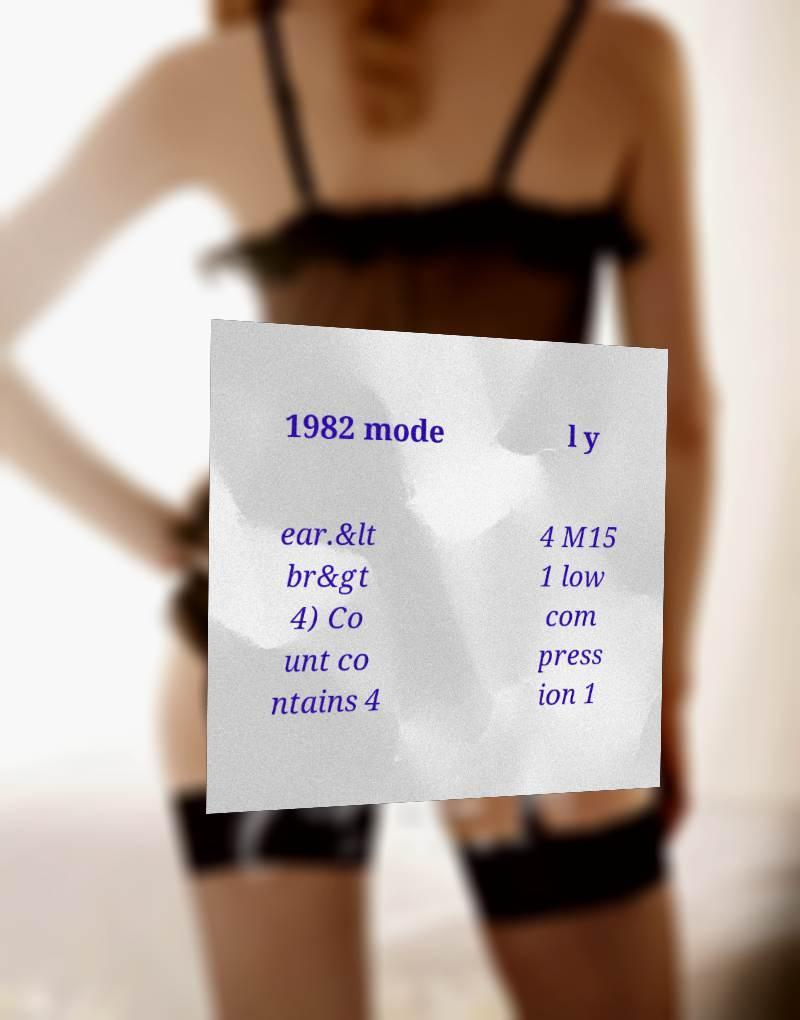Please read and relay the text visible in this image. What does it say? 1982 mode l y ear.&lt br&gt 4) Co unt co ntains 4 4 M15 1 low com press ion 1 